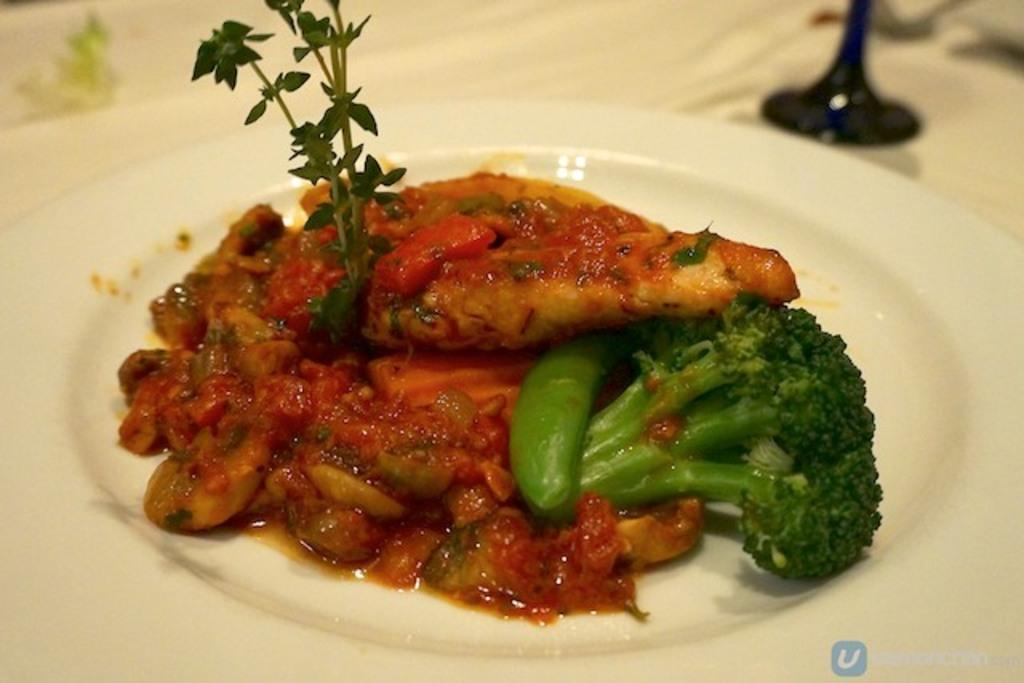What is on the plate that is visible in the image? There is food on a plate in the image. Where is the plate located in the image? The plate is placed on a table in the image. What can be seen in the background of the image? There are other unspecified objects in the background of the image. What type of crack can be heard in the image? There is no cracking sound present in the image. Is there a zipper visible on any of the objects in the image? There is no mention of a zipper in the image, as it only describes a plate of food and unspecified objects in the background. 